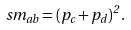<formula> <loc_0><loc_0><loc_500><loc_500>\ s m _ { a b } = ( p _ { c } + p _ { d } ) ^ { 2 } \, .</formula> 